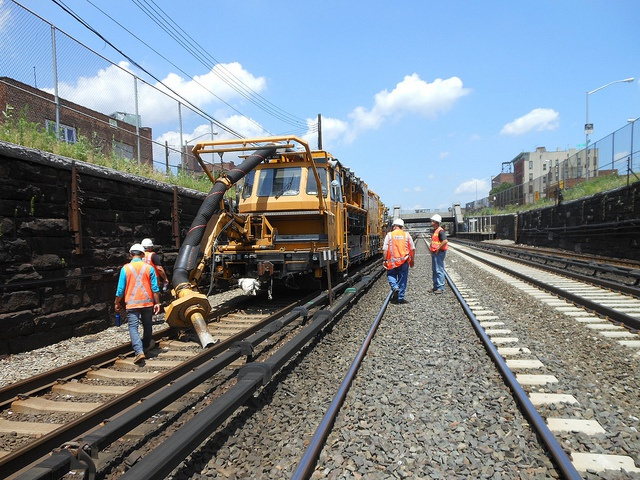Describe the objects in this image and their specific colors. I can see train in lavender, black, gray, and maroon tones, people in lavender, black, salmon, lightgray, and lightpink tones, people in lavender, navy, lightgray, tan, and black tones, people in lavender, darkblue, gray, navy, and black tones, and people in lavender, maroon, black, and white tones in this image. 